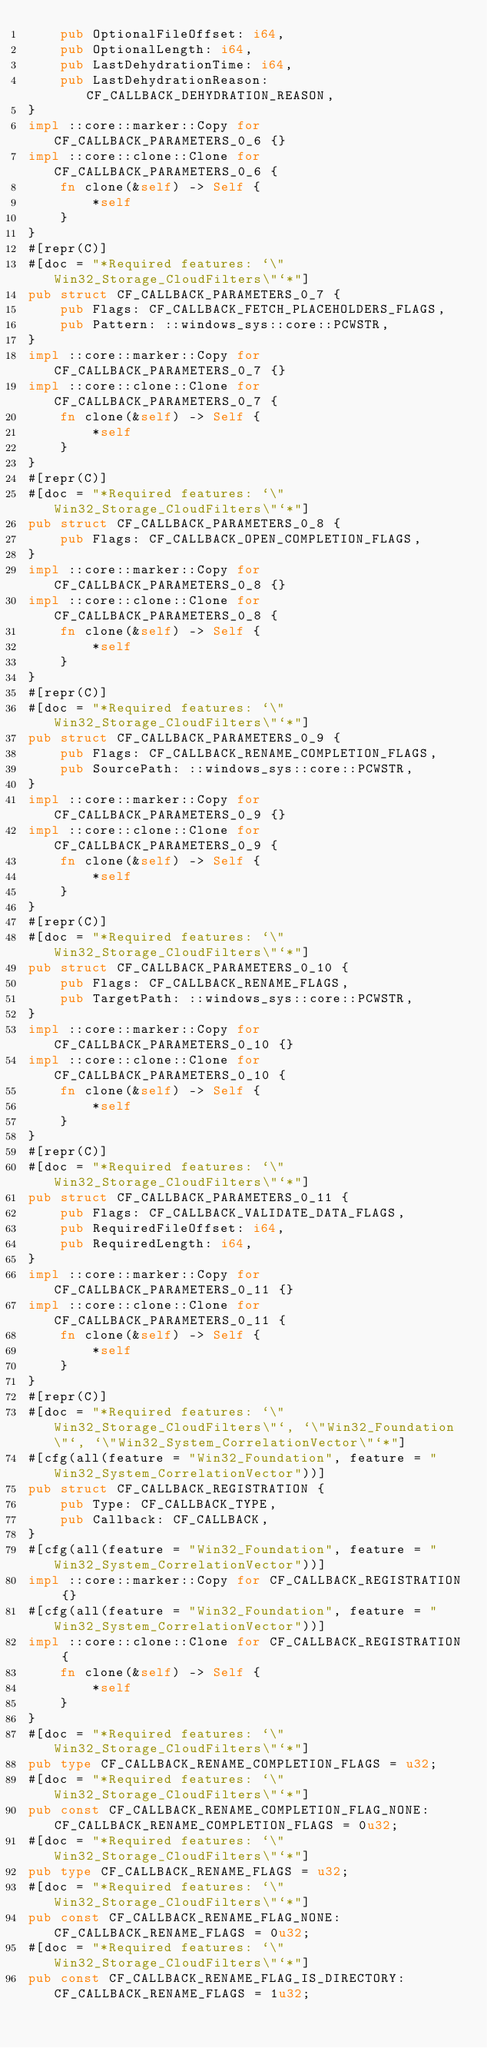<code> <loc_0><loc_0><loc_500><loc_500><_Rust_>    pub OptionalFileOffset: i64,
    pub OptionalLength: i64,
    pub LastDehydrationTime: i64,
    pub LastDehydrationReason: CF_CALLBACK_DEHYDRATION_REASON,
}
impl ::core::marker::Copy for CF_CALLBACK_PARAMETERS_0_6 {}
impl ::core::clone::Clone for CF_CALLBACK_PARAMETERS_0_6 {
    fn clone(&self) -> Self {
        *self
    }
}
#[repr(C)]
#[doc = "*Required features: `\"Win32_Storage_CloudFilters\"`*"]
pub struct CF_CALLBACK_PARAMETERS_0_7 {
    pub Flags: CF_CALLBACK_FETCH_PLACEHOLDERS_FLAGS,
    pub Pattern: ::windows_sys::core::PCWSTR,
}
impl ::core::marker::Copy for CF_CALLBACK_PARAMETERS_0_7 {}
impl ::core::clone::Clone for CF_CALLBACK_PARAMETERS_0_7 {
    fn clone(&self) -> Self {
        *self
    }
}
#[repr(C)]
#[doc = "*Required features: `\"Win32_Storage_CloudFilters\"`*"]
pub struct CF_CALLBACK_PARAMETERS_0_8 {
    pub Flags: CF_CALLBACK_OPEN_COMPLETION_FLAGS,
}
impl ::core::marker::Copy for CF_CALLBACK_PARAMETERS_0_8 {}
impl ::core::clone::Clone for CF_CALLBACK_PARAMETERS_0_8 {
    fn clone(&self) -> Self {
        *self
    }
}
#[repr(C)]
#[doc = "*Required features: `\"Win32_Storage_CloudFilters\"`*"]
pub struct CF_CALLBACK_PARAMETERS_0_9 {
    pub Flags: CF_CALLBACK_RENAME_COMPLETION_FLAGS,
    pub SourcePath: ::windows_sys::core::PCWSTR,
}
impl ::core::marker::Copy for CF_CALLBACK_PARAMETERS_0_9 {}
impl ::core::clone::Clone for CF_CALLBACK_PARAMETERS_0_9 {
    fn clone(&self) -> Self {
        *self
    }
}
#[repr(C)]
#[doc = "*Required features: `\"Win32_Storage_CloudFilters\"`*"]
pub struct CF_CALLBACK_PARAMETERS_0_10 {
    pub Flags: CF_CALLBACK_RENAME_FLAGS,
    pub TargetPath: ::windows_sys::core::PCWSTR,
}
impl ::core::marker::Copy for CF_CALLBACK_PARAMETERS_0_10 {}
impl ::core::clone::Clone for CF_CALLBACK_PARAMETERS_0_10 {
    fn clone(&self) -> Self {
        *self
    }
}
#[repr(C)]
#[doc = "*Required features: `\"Win32_Storage_CloudFilters\"`*"]
pub struct CF_CALLBACK_PARAMETERS_0_11 {
    pub Flags: CF_CALLBACK_VALIDATE_DATA_FLAGS,
    pub RequiredFileOffset: i64,
    pub RequiredLength: i64,
}
impl ::core::marker::Copy for CF_CALLBACK_PARAMETERS_0_11 {}
impl ::core::clone::Clone for CF_CALLBACK_PARAMETERS_0_11 {
    fn clone(&self) -> Self {
        *self
    }
}
#[repr(C)]
#[doc = "*Required features: `\"Win32_Storage_CloudFilters\"`, `\"Win32_Foundation\"`, `\"Win32_System_CorrelationVector\"`*"]
#[cfg(all(feature = "Win32_Foundation", feature = "Win32_System_CorrelationVector"))]
pub struct CF_CALLBACK_REGISTRATION {
    pub Type: CF_CALLBACK_TYPE,
    pub Callback: CF_CALLBACK,
}
#[cfg(all(feature = "Win32_Foundation", feature = "Win32_System_CorrelationVector"))]
impl ::core::marker::Copy for CF_CALLBACK_REGISTRATION {}
#[cfg(all(feature = "Win32_Foundation", feature = "Win32_System_CorrelationVector"))]
impl ::core::clone::Clone for CF_CALLBACK_REGISTRATION {
    fn clone(&self) -> Self {
        *self
    }
}
#[doc = "*Required features: `\"Win32_Storage_CloudFilters\"`*"]
pub type CF_CALLBACK_RENAME_COMPLETION_FLAGS = u32;
#[doc = "*Required features: `\"Win32_Storage_CloudFilters\"`*"]
pub const CF_CALLBACK_RENAME_COMPLETION_FLAG_NONE: CF_CALLBACK_RENAME_COMPLETION_FLAGS = 0u32;
#[doc = "*Required features: `\"Win32_Storage_CloudFilters\"`*"]
pub type CF_CALLBACK_RENAME_FLAGS = u32;
#[doc = "*Required features: `\"Win32_Storage_CloudFilters\"`*"]
pub const CF_CALLBACK_RENAME_FLAG_NONE: CF_CALLBACK_RENAME_FLAGS = 0u32;
#[doc = "*Required features: `\"Win32_Storage_CloudFilters\"`*"]
pub const CF_CALLBACK_RENAME_FLAG_IS_DIRECTORY: CF_CALLBACK_RENAME_FLAGS = 1u32;</code> 